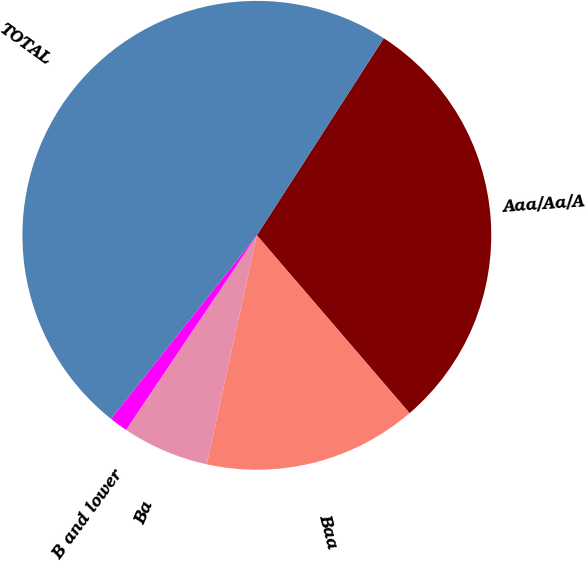<chart> <loc_0><loc_0><loc_500><loc_500><pie_chart><fcel>Aaa/Aa/A<fcel>Baa<fcel>Ba<fcel>B and lower<fcel>TOTAL<nl><fcel>29.6%<fcel>14.72%<fcel>5.99%<fcel>1.27%<fcel>48.42%<nl></chart> 